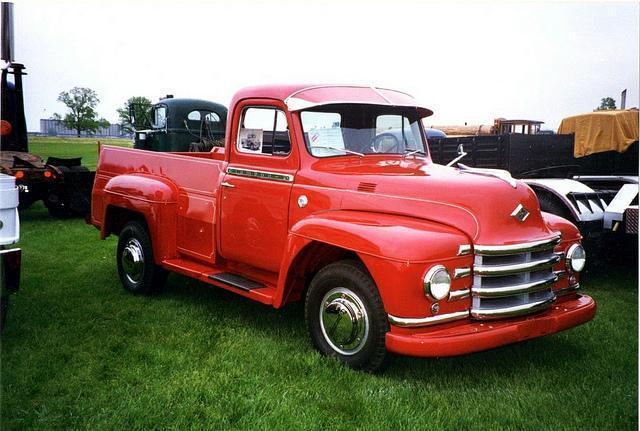What is this red truck for?
Pick the correct solution from the four options below to address the question.
Options: Refurbishment, rent, sale, repair. Sale. 